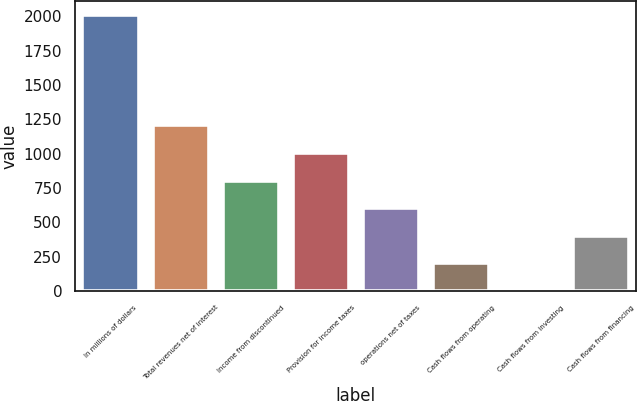<chart> <loc_0><loc_0><loc_500><loc_500><bar_chart><fcel>In millions of dollars<fcel>Total revenues net of interest<fcel>Income from discontinued<fcel>Provision for income taxes<fcel>operations net of taxes<fcel>Cash flows from operating<fcel>Cash flows from investing<fcel>Cash flows from financing<nl><fcel>2009<fcel>1205.8<fcel>804.2<fcel>1005<fcel>603.4<fcel>201.8<fcel>1<fcel>402.6<nl></chart> 